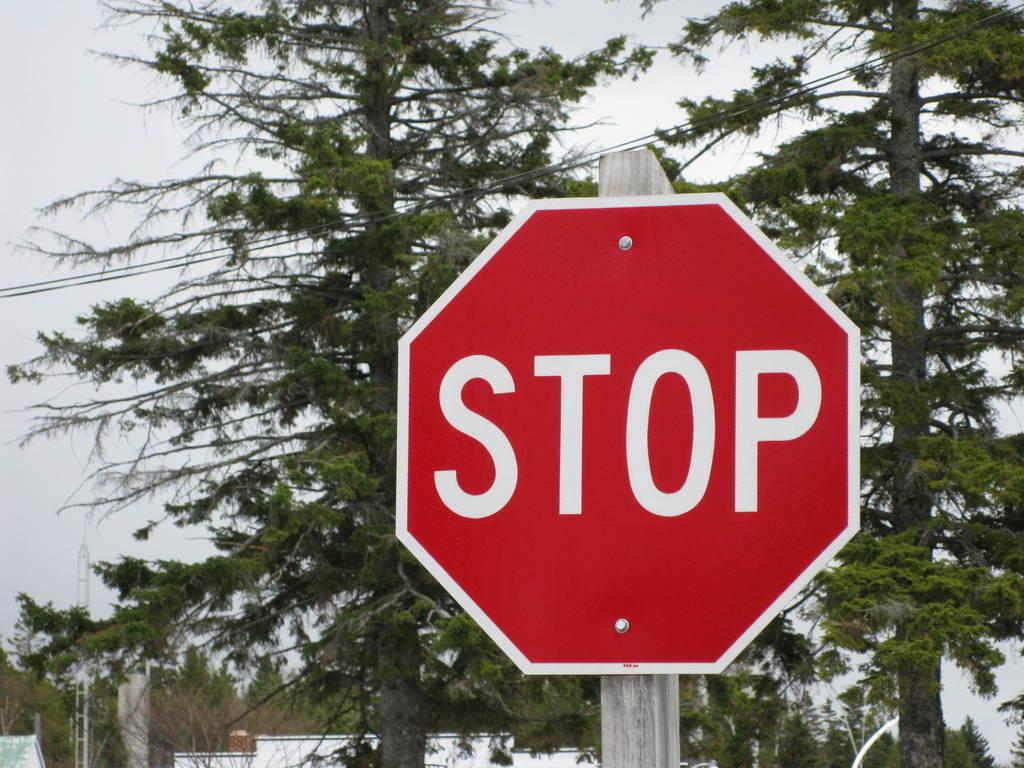<image>
Render a clear and concise summary of the photo. A stop sign is shown with trees in the background. 